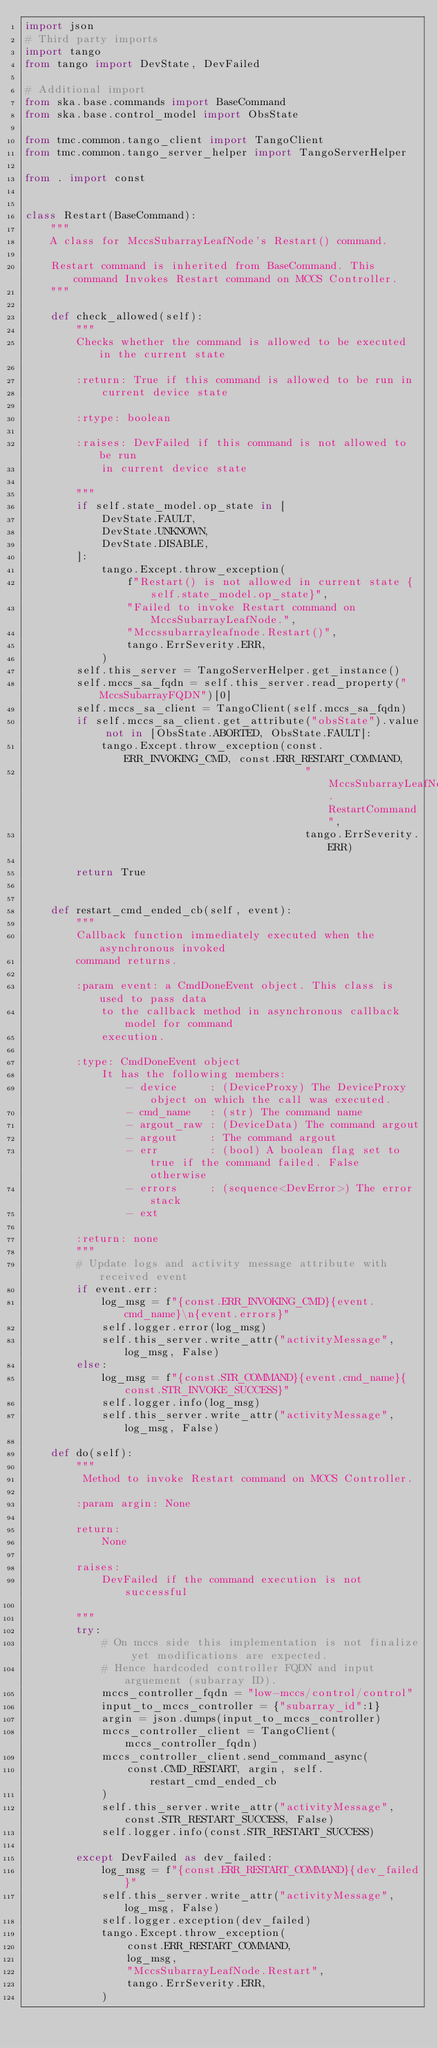Convert code to text. <code><loc_0><loc_0><loc_500><loc_500><_Python_>import json
# Third party imports
import tango
from tango import DevState, DevFailed

# Additional import
from ska.base.commands import BaseCommand
from ska.base.control_model import ObsState

from tmc.common.tango_client import TangoClient
from tmc.common.tango_server_helper import TangoServerHelper

from . import const


class Restart(BaseCommand):
    """
    A class for MccsSubarrayLeafNode's Restart() command.

    Restart command is inherited from BaseCommand. This command Invokes Restart command on MCCS Controller.
    """

    def check_allowed(self):
        """
        Checks whether the command is allowed to be executed in the current state

        :return: True if this command is allowed to be run in
            current device state

        :rtype: boolean

        :raises: DevFailed if this command is not allowed to be run
            in current device state

        """
        if self.state_model.op_state in [
            DevState.FAULT,
            DevState.UNKNOWN,
            DevState.DISABLE,
        ]:
            tango.Except.throw_exception(
                f"Restart() is not allowed in current state {self.state_model.op_state}",
                "Failed to invoke Restart command on MccsSubarrayLeafNode.",
                "Mccssubarrayleafnode.Restart()",
                tango.ErrSeverity.ERR,
            )
        self.this_server = TangoServerHelper.get_instance()
        self.mccs_sa_fqdn = self.this_server.read_property("MccsSubarrayFQDN")[0]
        self.mccs_sa_client = TangoClient(self.mccs_sa_fqdn)
        if self.mccs_sa_client.get_attribute("obsState").value not in [ObsState.ABORTED, ObsState.FAULT]:
            tango.Except.throw_exception(const.ERR_INVOKING_CMD, const.ERR_RESTART_COMMAND,
                                            "MccsSubarrayLeafNode.RestartCommand",
                                            tango.ErrSeverity.ERR)
        
        return True


    def restart_cmd_ended_cb(self, event):
        """
        Callback function immediately executed when the asynchronous invoked
        command returns.

        :param event: a CmdDoneEvent object. This class is used to pass data
            to the callback method in asynchronous callback model for command
            execution.

        :type: CmdDoneEvent object
            It has the following members:
                - device     : (DeviceProxy) The DeviceProxy object on which the call was executed.
                - cmd_name   : (str) The command name
                - argout_raw : (DeviceData) The command argout
                - argout     : The command argout
                - err        : (bool) A boolean flag set to true if the command failed. False otherwise
                - errors     : (sequence<DevError>) The error stack
                - ext

        :return: none
        """
        # Update logs and activity message attribute with received event
        if event.err:
            log_msg = f"{const.ERR_INVOKING_CMD}{event.cmd_name}\n{event.errors}"
            self.logger.error(log_msg)
            self.this_server.write_attr("activityMessage", log_msg, False)
        else:
            log_msg = f"{const.STR_COMMAND}{event.cmd_name}{const.STR_INVOKE_SUCCESS}"
            self.logger.info(log_msg)
            self.this_server.write_attr("activityMessage", log_msg, False)

    def do(self):
        """
         Method to invoke Restart command on MCCS Controller.

        :param argin: None

        return:
            None

        raises:
            DevFailed if the command execution is not successful

        """
        try:
            # On mccs side this implementation is not finalize yet modifications are expected.
            # Hence hardcoded controller FQDN and input arguement (subarray ID).
            mccs_controller_fqdn = "low-mccs/control/control"
            input_to_mccs_controller = {"subarray_id":1}
            argin = json.dumps(input_to_mccs_controller)
            mccs_controller_client = TangoClient(mccs_controller_fqdn)
            mccs_controller_client.send_command_async(
                const.CMD_RESTART, argin, self.restart_cmd_ended_cb
            )
            self.this_server.write_attr("activityMessage", const.STR_RESTART_SUCCESS, False)
            self.logger.info(const.STR_RESTART_SUCCESS)

        except DevFailed as dev_failed:
            log_msg = f"{const.ERR_RESTART_COMMAND}{dev_failed}"
            self.this_server.write_attr("activityMessage", log_msg, False)
            self.logger.exception(dev_failed)
            tango.Except.throw_exception(
                const.ERR_RESTART_COMMAND,
                log_msg,
                "MccsSubarrayLeafNode.Restart",
                tango.ErrSeverity.ERR,
            )
</code> 